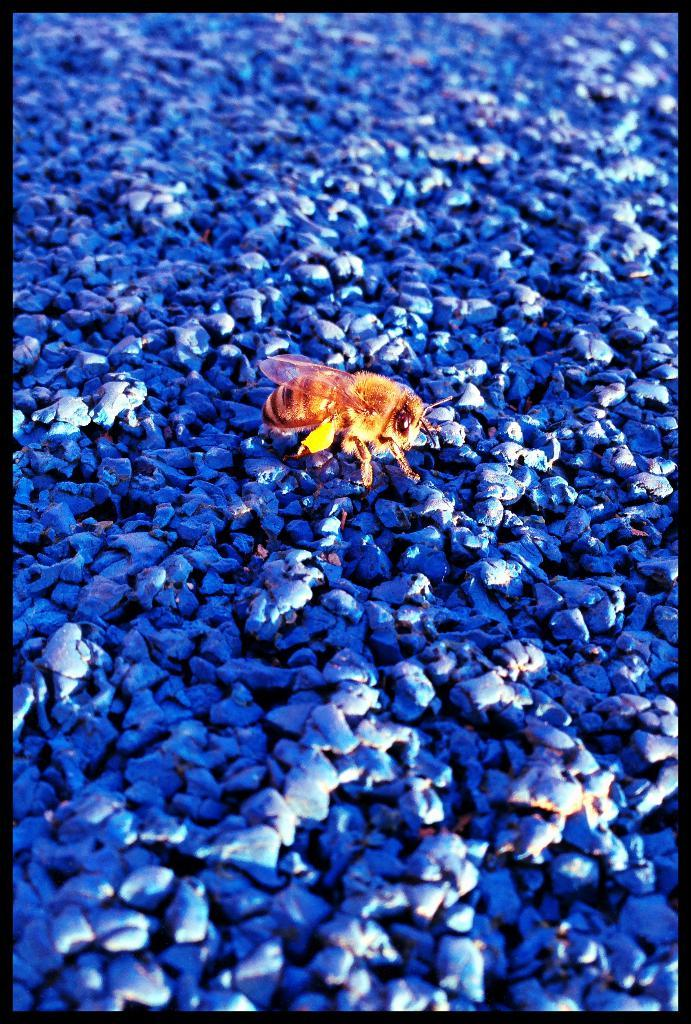What type of creature can be seen in the image? There is an insect in the image. What other objects are present in the image besides the insect? There are blue stones in the image. What type of joke is being told by the insect in the image? There is no indication in the image that the insect is telling a joke, as it is simply an insect and not a sentient being capable of telling jokes. 